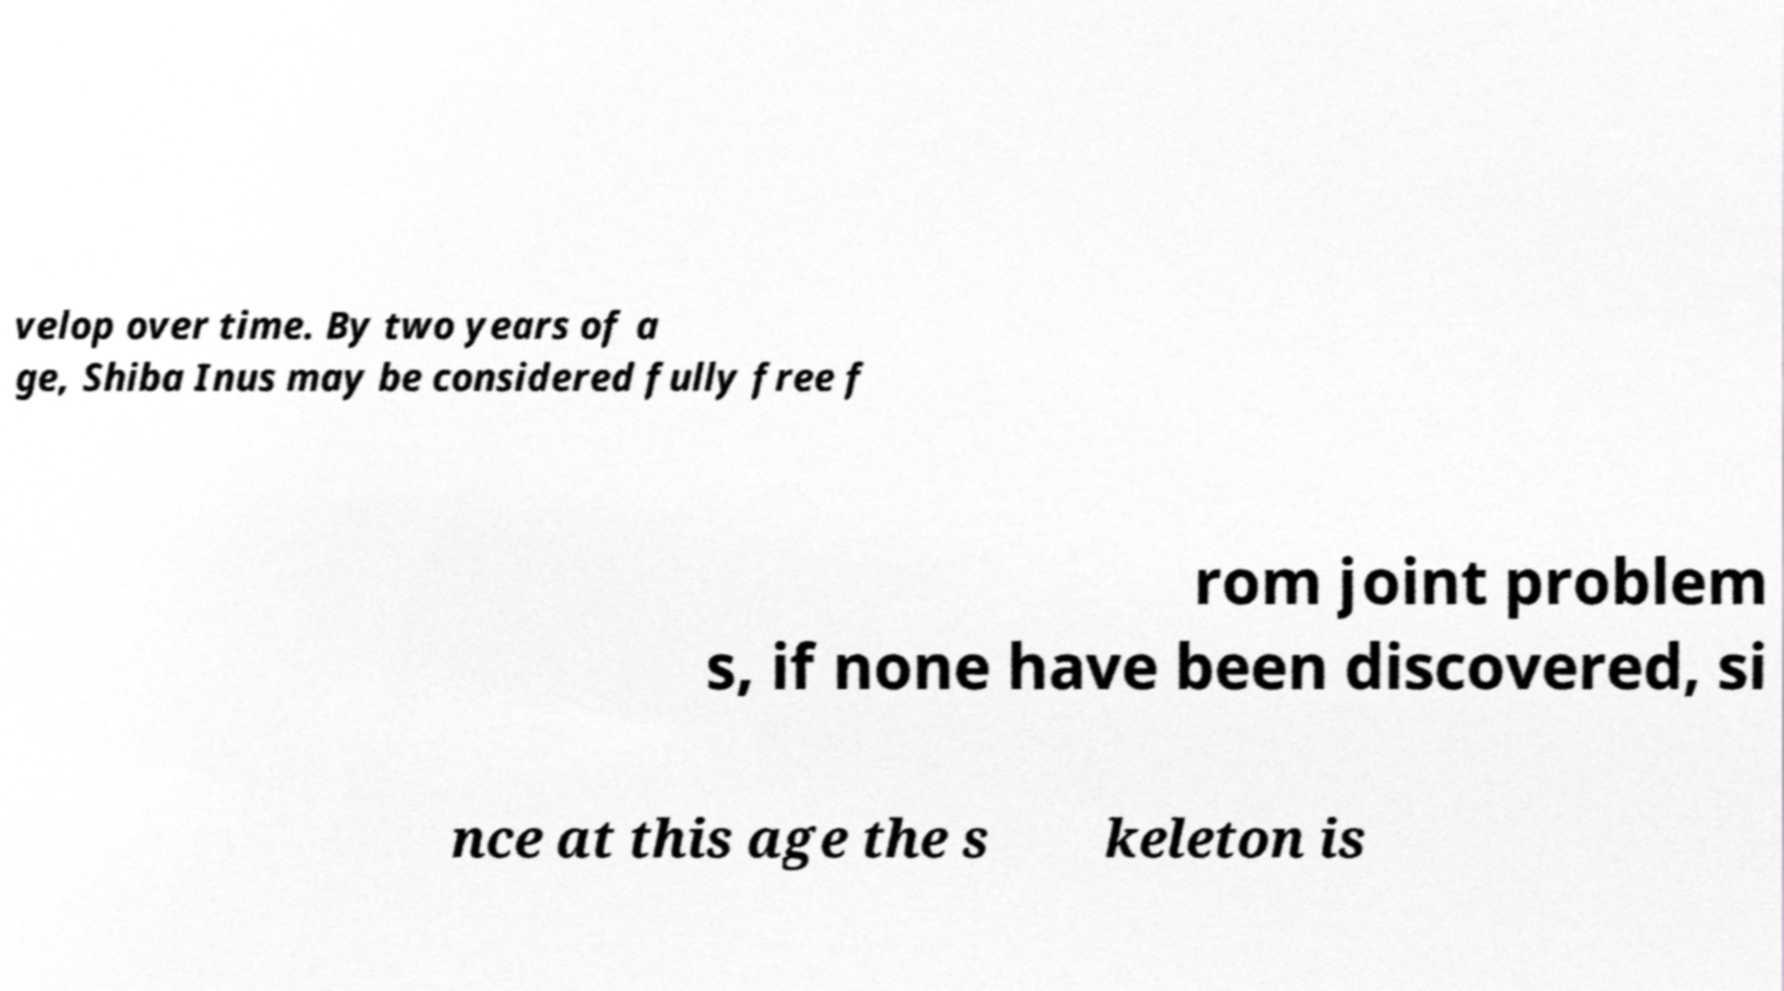I need the written content from this picture converted into text. Can you do that? velop over time. By two years of a ge, Shiba Inus may be considered fully free f rom joint problem s, if none have been discovered, si nce at this age the s keleton is 